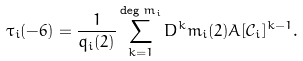<formula> <loc_0><loc_0><loc_500><loc_500>\tau _ { i } ( - 6 ) & = \frac { 1 } { q _ { i } ( 2 ) } \sum _ { k = 1 } ^ { \deg m _ { i } } D ^ { k } m _ { i } ( 2 ) A [ \mathcal { C } _ { i } ] ^ { k - 1 } .</formula> 